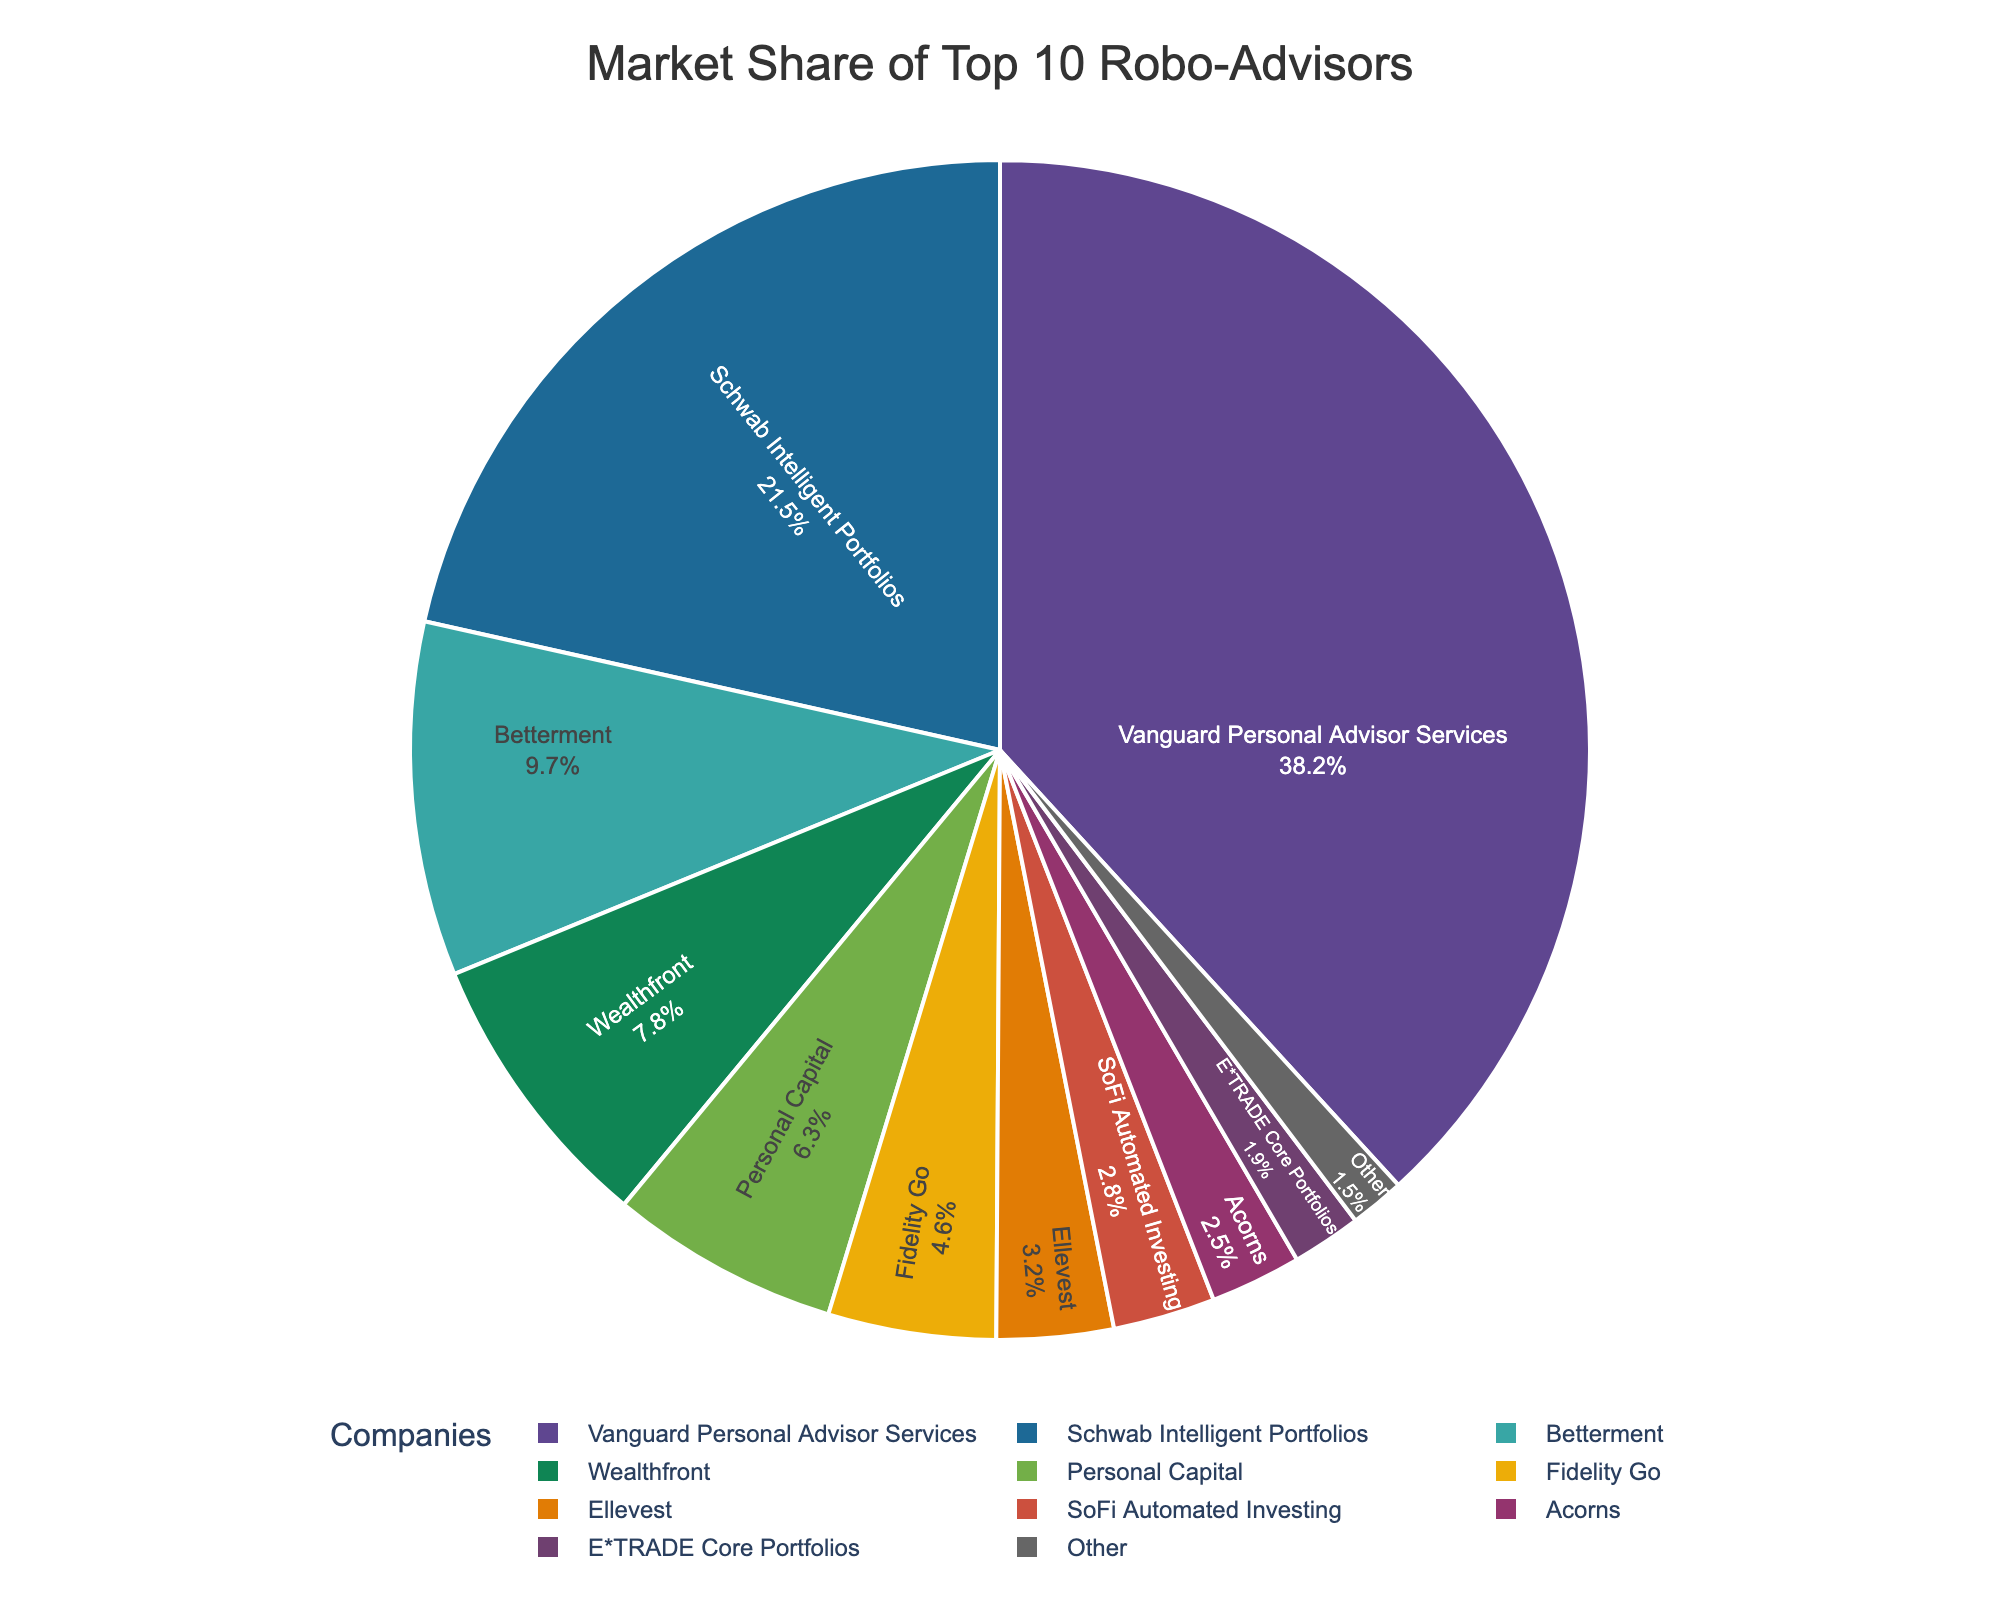Which company has the largest market share? By looking at the pie chart, the company with the largest slice is Vanguard Personal Advisor Services. This is visually evident and confirmed by the percentage value shown on the chart.
Answer: Vanguard Personal Advisor Services Which company has a market share less than 5% and is also less than SoFi Automated Investing? By looking at the portion sizes, SoFi Automated Investing has a market share of 2.8%. Any company with a smaller slice than 2.8% is E*TRADE Core Portfolios. Comparing the percentages, E*TRADE Core Portfolios has a market share of 1.9%, which is less than 5% and also less than SoFi Automated Investing.
Answer: E*TRADE Core Portfolios How do the combined market shares of Wealthfront and Personal Capital compare to Schwab Intelligent Portfolios' market share? Wealthfront has 7.8% and Personal Capital has 6.3%, so their combined market share is 7.8 + 6.3 = 14.1%. Schwab Intelligent Portfolios has 21.5%. 14.1% is less than 21.5%, so Wealthfront and Personal Capital combined have a smaller market share compared to Schwab Intelligent Portfolios.
Answer: 14.1% is less than 21.5% What is the market share difference between Betterment and Fidelity Go? Betterment has a market share of 9.7%, and Fidelity Go has 4.6%. The difference is calculated by subtracting these values: 9.7 - 4.6 = 5.1%.
Answer: 5.1% Which companies have market shares closest in value? By comparing the market share values, Acorns (2.5%) and E*TRADE Core Portfolios (1.9%) have the closest market shares. The difference between their market shares is 2.5 - 1.9 = 0.6, which is smaller compared to other pairs.
Answer: Acorns and E*TRADE Core Portfolios 